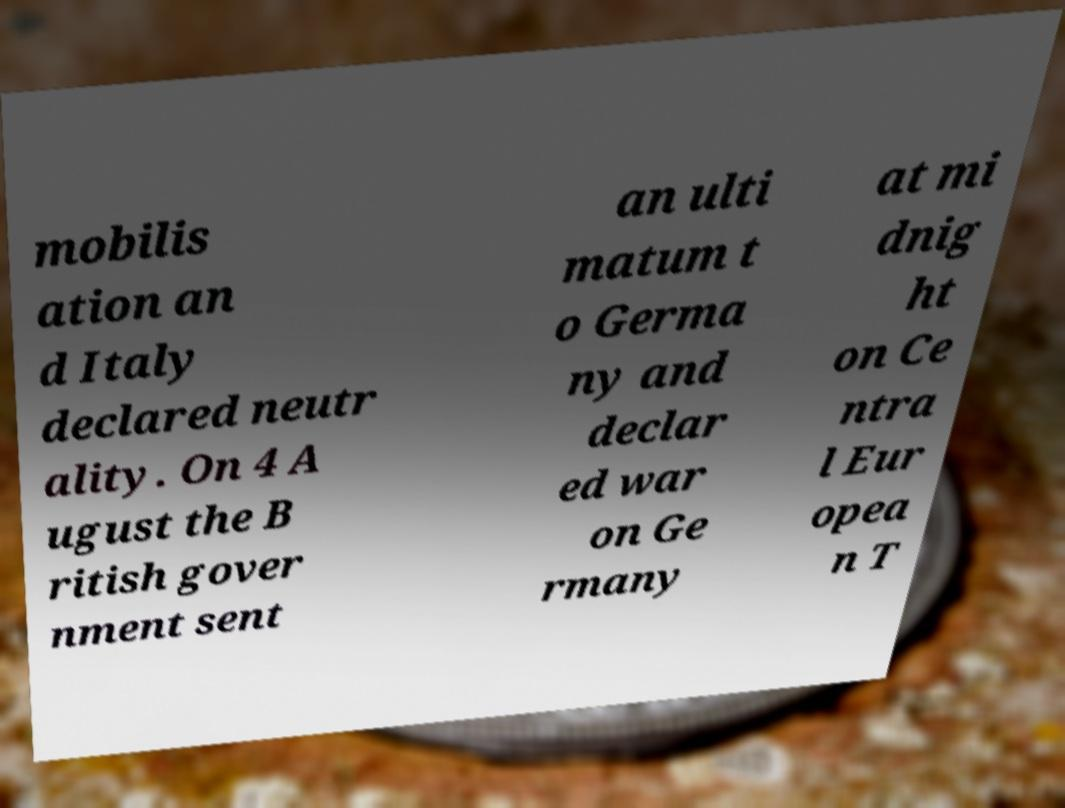Please identify and transcribe the text found in this image. mobilis ation an d Italy declared neutr ality. On 4 A ugust the B ritish gover nment sent an ulti matum t o Germa ny and declar ed war on Ge rmany at mi dnig ht on Ce ntra l Eur opea n T 